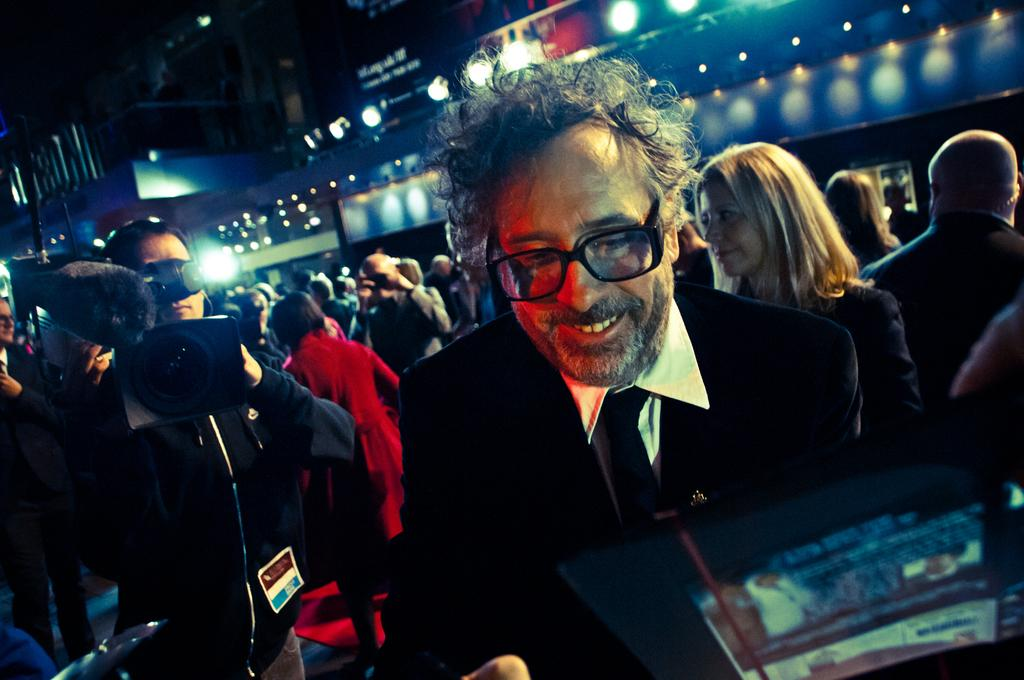What is the main structure in the image? There is a building in the image. What is happening in front of the building? There is a crowd in front of the building. Can you describe the person with a camera in the image? A man holding a camera is present in the image. When was the image taken? The image was taken during nighttime. What can be seen on the building? There are lights visible on the building. Where is the sofa located in the image? There is no sofa present in the image. Who is the porter assisting in the image? There is no porter present in the image. 